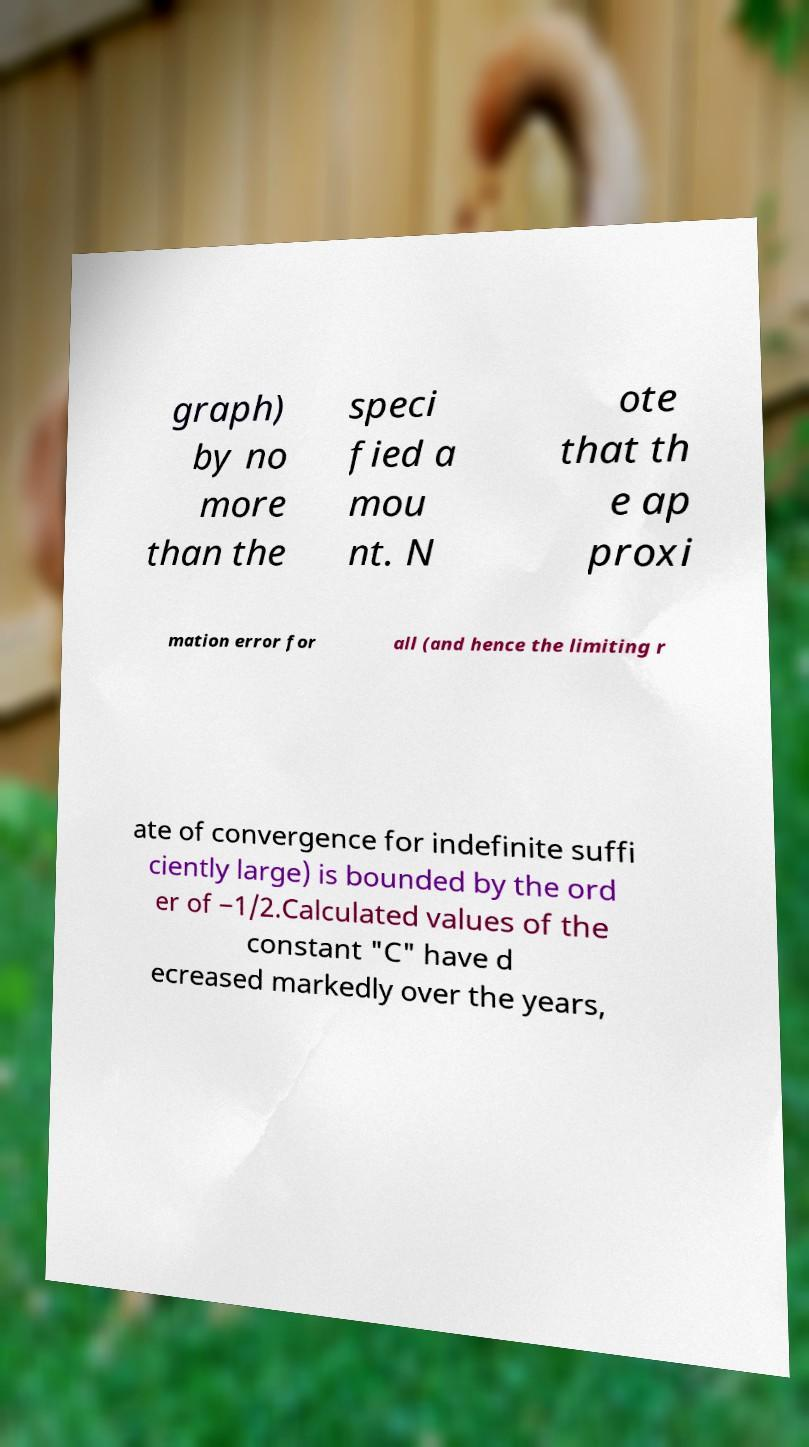Could you extract and type out the text from this image? graph) by no more than the speci fied a mou nt. N ote that th e ap proxi mation error for all (and hence the limiting r ate of convergence for indefinite suffi ciently large) is bounded by the ord er of −1/2.Calculated values of the constant "C" have d ecreased markedly over the years, 